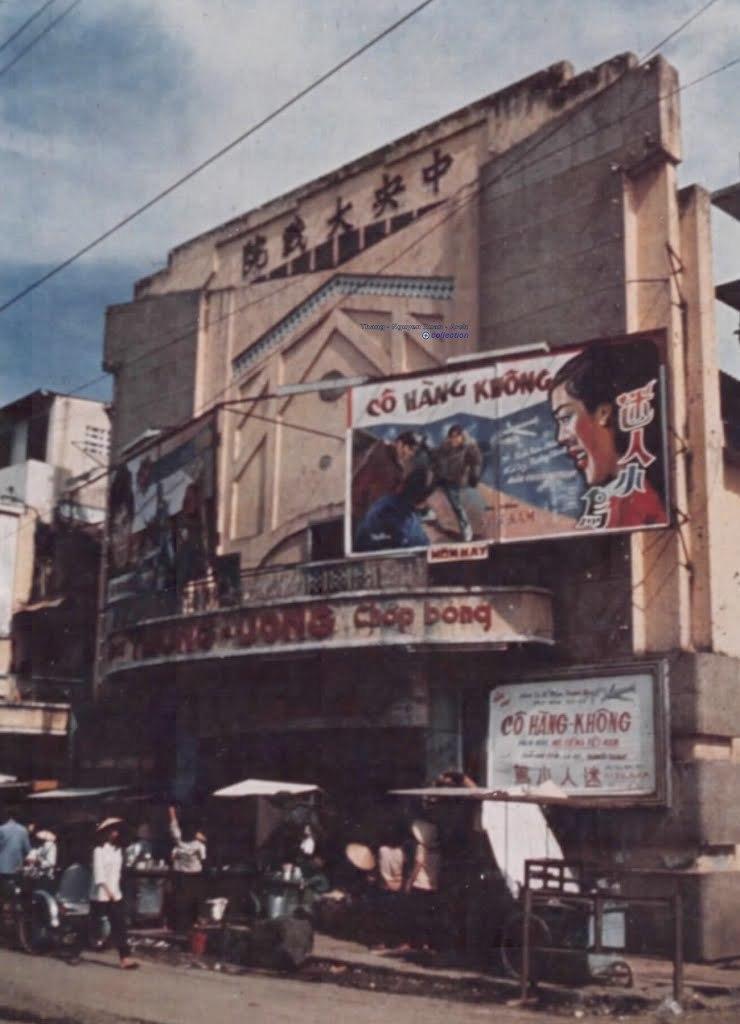Could you give a brief overview of what you see in this image? In this picture I can see there is a building here and it has some banners and there are few people walking on the road and there are some electric cables and the sky is clear. 